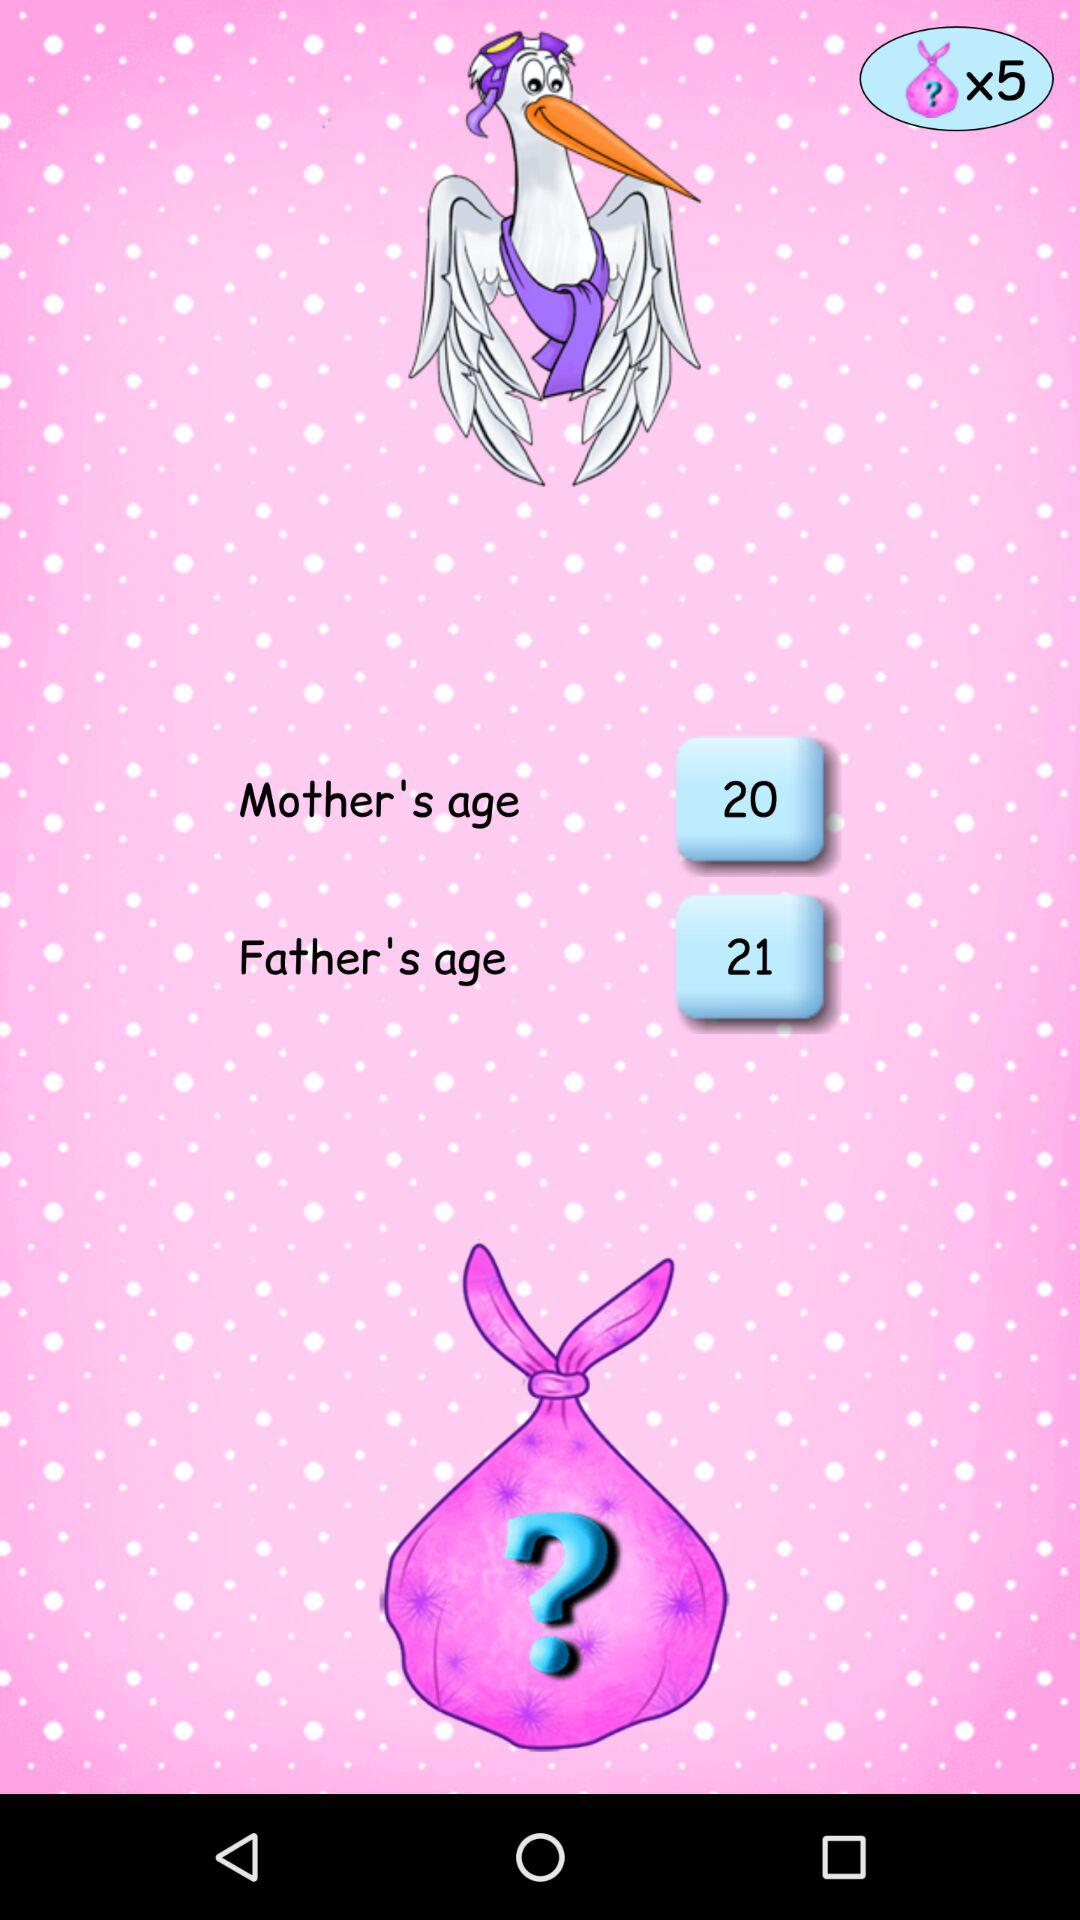What is the mother's age? The mother's age is 20. 